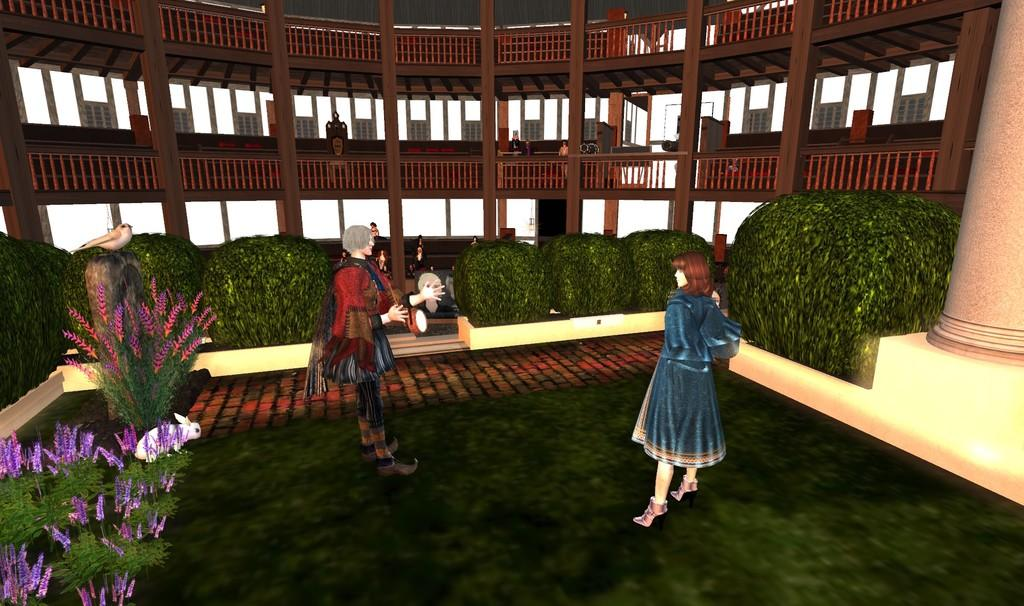What type of picture is the image? The image is an animated picture. Can you describe the subjects in the image? There is a group of people, a bird, and a rabbit in the image. What else can be seen in the image? There are plants and a building in the background of the image. How many plastic bottles are visible in the image? There are no plastic bottles present in the image. What type of flock is the bird a part of in the image? The image does not depict a flock of birds; there is only one bird present. 